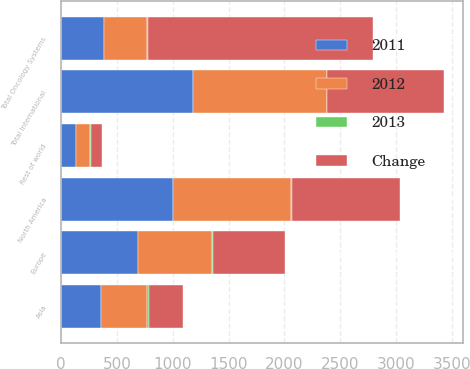<chart> <loc_0><loc_0><loc_500><loc_500><stacked_bar_chart><ecel><fcel>North America<fcel>Europe<fcel>Asia<fcel>Rest of world<fcel>Total International<fcel>Total Oncology Systems<nl><fcel>2012<fcel>1058<fcel>663<fcel>412<fcel>120<fcel>1195<fcel>385.5<nl><fcel>2013<fcel>5<fcel>4<fcel>15<fcel>11<fcel>1<fcel>3<nl><fcel>2011<fcel>1005<fcel>690<fcel>359<fcel>135<fcel>1184<fcel>385.5<nl><fcel>Change<fcel>971<fcel>650<fcel>303<fcel>98<fcel>1051<fcel>2022<nl></chart> 